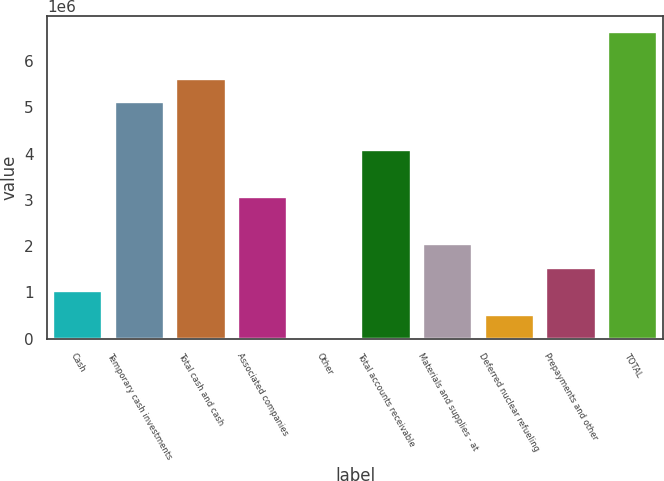Convert chart to OTSL. <chart><loc_0><loc_0><loc_500><loc_500><bar_chart><fcel>Cash<fcel>Temporary cash investments<fcel>Total cash and cash<fcel>Associated companies<fcel>Other<fcel>Total accounts receivable<fcel>Materials and supplies - at<fcel>Deferred nuclear refueling<fcel>Prepayments and other<fcel>TOTAL<nl><fcel>1.0247e+06<fcel>5.10523e+06<fcel>5.61529e+06<fcel>3.06497e+06<fcel>4574<fcel>4.0851e+06<fcel>2.04484e+06<fcel>514639<fcel>1.53477e+06<fcel>6.63542e+06<nl></chart> 